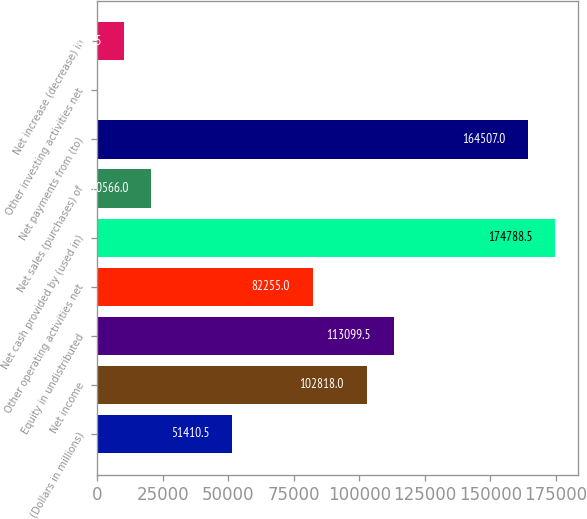<chart> <loc_0><loc_0><loc_500><loc_500><bar_chart><fcel>(Dollars in millions)<fcel>Net income<fcel>Equity in undistributed<fcel>Other operating activities net<fcel>Net cash provided by (used in)<fcel>Net sales (purchases) of<fcel>Net payments from (to)<fcel>Other investing activities net<fcel>Net increase (decrease) in<nl><fcel>51410.5<fcel>102818<fcel>113100<fcel>82255<fcel>174788<fcel>20566<fcel>164507<fcel>3<fcel>10284.5<nl></chart> 